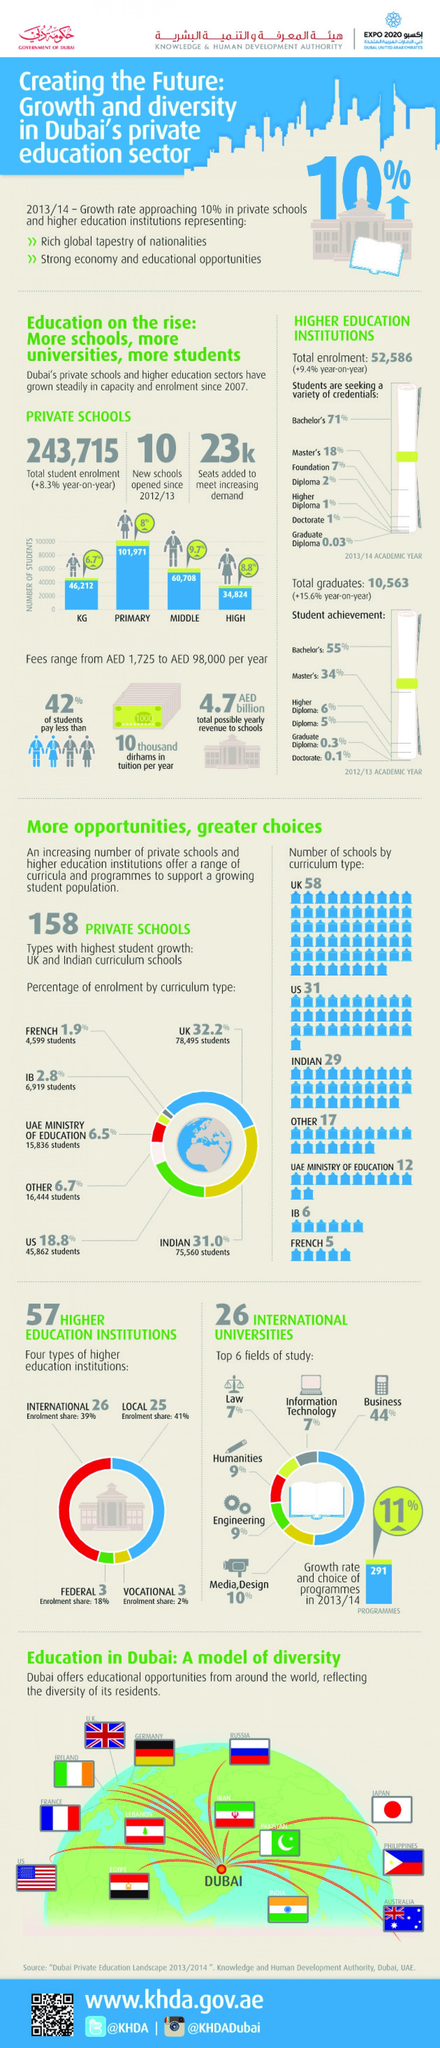List a handful of essential elements in this visual. According to recent data, a total of 23,000 new seats have been added in private schools to accommodate the growing demand for education. A total of 11,518 students have been enrolled in IB and French curriculum schools together. The yearly increase in enrollment rate in private schools has been approximately +8.3%. There are a total of 6 federal and vocational institutions. The total number of students in KG and high schools is 81036. 